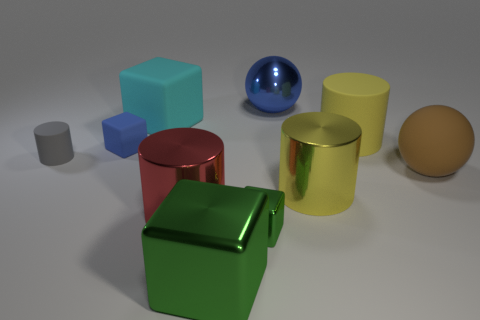Subtract all balls. How many objects are left? 8 Subtract all big rubber cubes. Subtract all big objects. How many objects are left? 2 Add 7 large cyan things. How many large cyan things are left? 8 Add 8 red metallic cylinders. How many red metallic cylinders exist? 9 Subtract 0 blue cylinders. How many objects are left? 10 